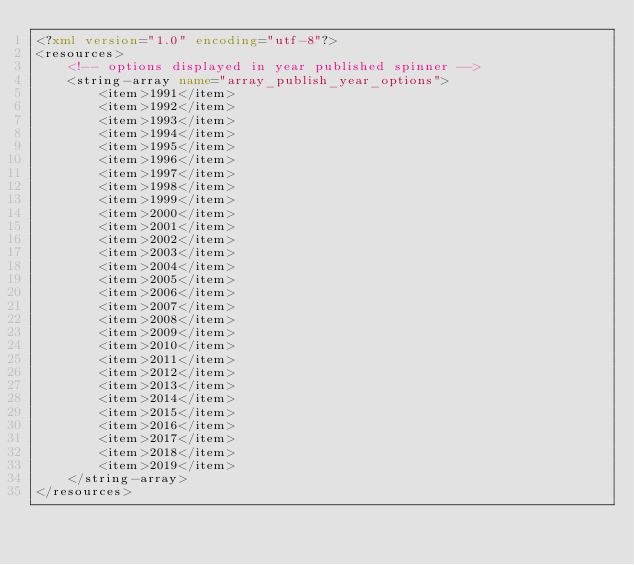<code> <loc_0><loc_0><loc_500><loc_500><_XML_><?xml version="1.0" encoding="utf-8"?>
<resources>
    <!-- options displayed in year published spinner -->
    <string-array name="array_publish_year_options">
        <item>1991</item>
        <item>1992</item>
        <item>1993</item>
        <item>1994</item>
        <item>1995</item>
        <item>1996</item>
        <item>1997</item>
        <item>1998</item>
        <item>1999</item>
        <item>2000</item>
        <item>2001</item>
        <item>2002</item>
        <item>2003</item>
        <item>2004</item>
        <item>2005</item>
        <item>2006</item>
        <item>2007</item>
        <item>2008</item>
        <item>2009</item>
        <item>2010</item>
        <item>2011</item>
        <item>2012</item>
        <item>2013</item>
        <item>2014</item>
        <item>2015</item>
        <item>2016</item>
        <item>2017</item>
        <item>2018</item>
        <item>2019</item>
    </string-array>
</resources></code> 